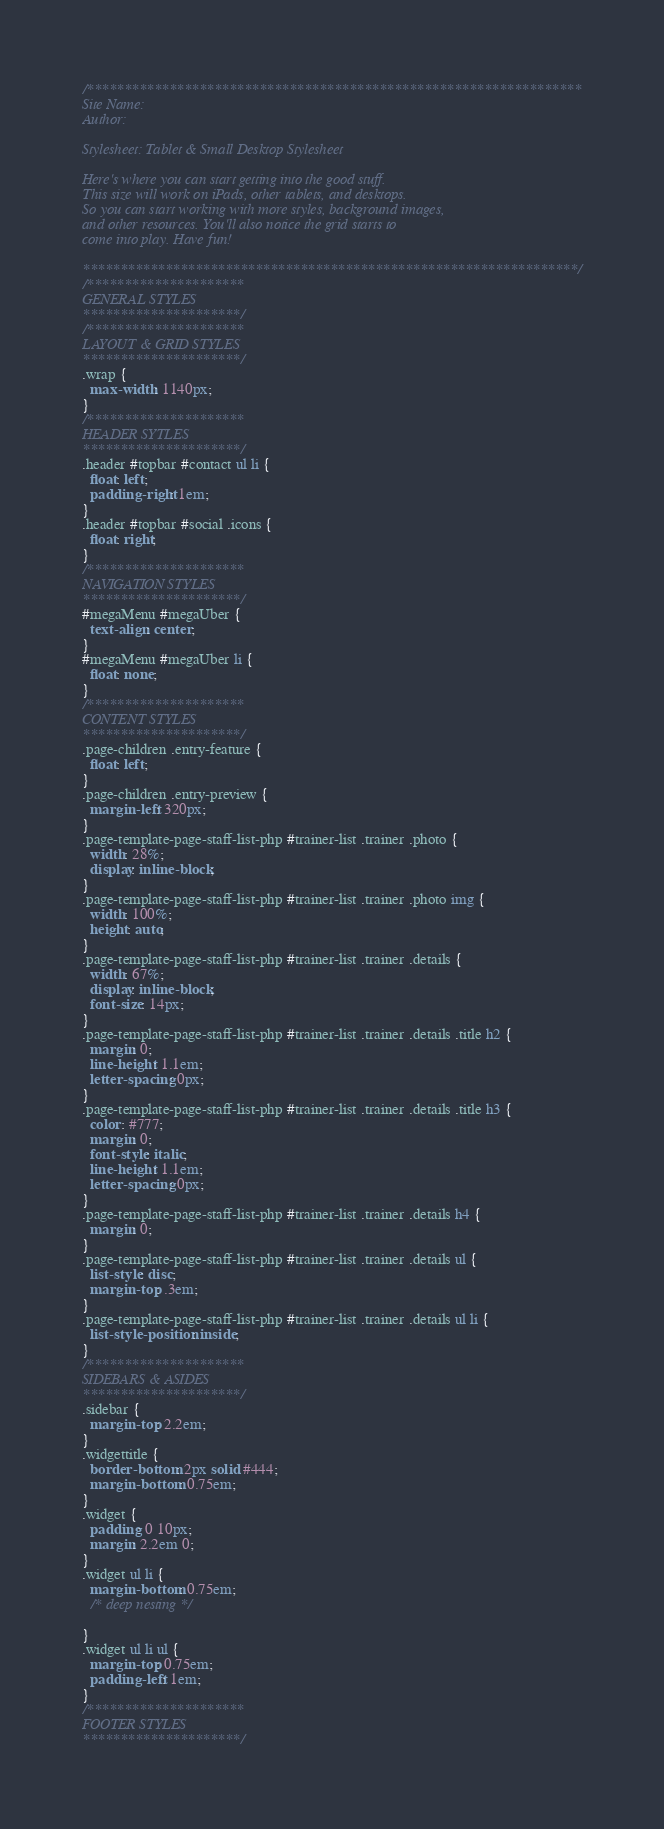<code> <loc_0><loc_0><loc_500><loc_500><_CSS_>/******************************************************************
Site Name:
Author:

Stylesheet: Tablet & Small Desktop Stylesheet

Here's where you can start getting into the good stuff.
This size will work on iPads, other tablets, and desktops.
So you can start working with more styles, background images,
and other resources. You'll also notice the grid starts to
come into play. Have fun!

******************************************************************/
/*********************
GENERAL STYLES
*********************/
/*********************
LAYOUT & GRID STYLES
*********************/
.wrap {
  max-width: 1140px;
}
/*********************
HEADER SYTLES
*********************/
.header #topbar #contact ul li {
  float: left;
  padding-right: 1em;
}
.header #topbar #social .icons {
  float: right;
}
/*********************
NAVIGATION STYLES
*********************/
#megaMenu #megaUber {
  text-align: center;
}
#megaMenu #megaUber li {
  float: none;
}
/*********************
CONTENT STYLES
*********************/
.page-children .entry-feature {
  float: left;
}
.page-children .entry-preview {
  margin-left: 320px;
}
.page-template-page-staff-list-php #trainer-list .trainer .photo {
  width: 28%;
  display: inline-block;
}
.page-template-page-staff-list-php #trainer-list .trainer .photo img {
  width: 100%;
  height: auto;
}
.page-template-page-staff-list-php #trainer-list .trainer .details {
  width: 67%;
  display: inline-block;
  font-size: 14px;
}
.page-template-page-staff-list-php #trainer-list .trainer .details .title h2 {
  margin: 0;
  line-height: 1.1em;
  letter-spacing: 0px;
}
.page-template-page-staff-list-php #trainer-list .trainer .details .title h3 {
  color: #777;
  margin: 0;
  font-style: italic;
  line-height: 1.1em;
  letter-spacing: 0px;
}
.page-template-page-staff-list-php #trainer-list .trainer .details h4 {
  margin: 0;
}
.page-template-page-staff-list-php #trainer-list .trainer .details ul {
  list-style: disc;
  margin-top: .3em;
}
.page-template-page-staff-list-php #trainer-list .trainer .details ul li {
  list-style-position: inside;
}
/*********************
SIDEBARS & ASIDES
*********************/
.sidebar {
  margin-top: 2.2em;
}
.widgettitle {
  border-bottom: 2px solid #444;
  margin-bottom: 0.75em;
}
.widget {
  padding: 0 10px;
  margin: 2.2em 0;
}
.widget ul li {
  margin-bottom: 0.75em;
  /* deep nesting */

}
.widget ul li ul {
  margin-top: 0.75em;
  padding-left: 1em;
}
/*********************
FOOTER STYLES
*********************/
</code> 